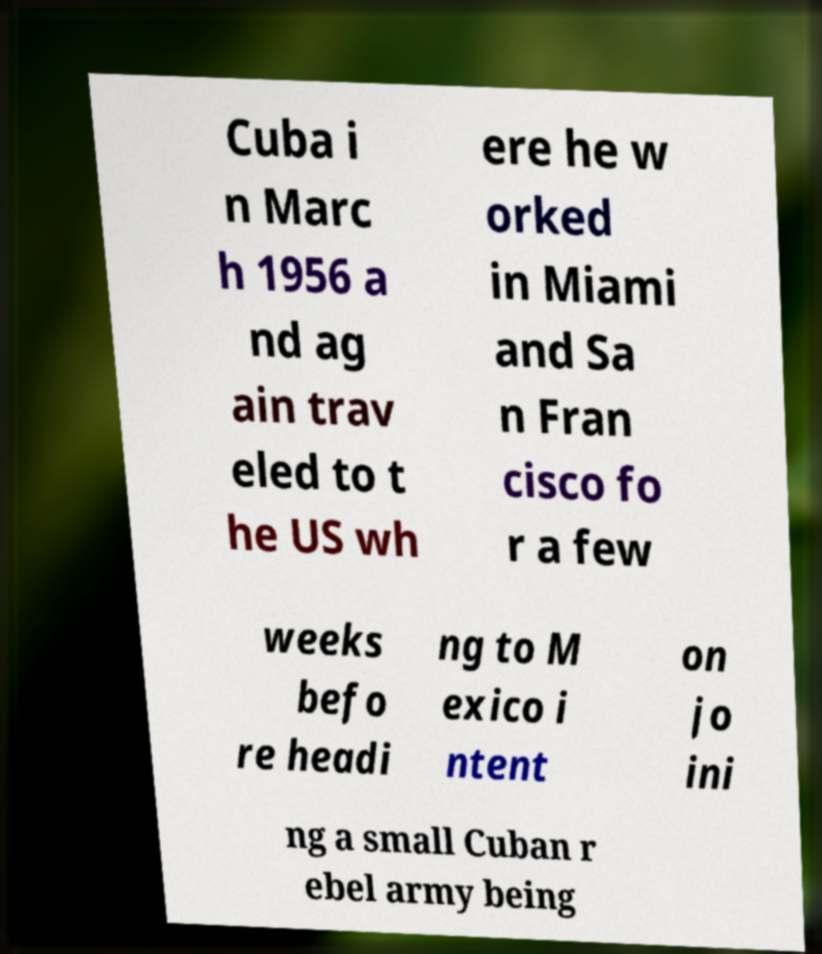For documentation purposes, I need the text within this image transcribed. Could you provide that? Cuba i n Marc h 1956 a nd ag ain trav eled to t he US wh ere he w orked in Miami and Sa n Fran cisco fo r a few weeks befo re headi ng to M exico i ntent on jo ini ng a small Cuban r ebel army being 